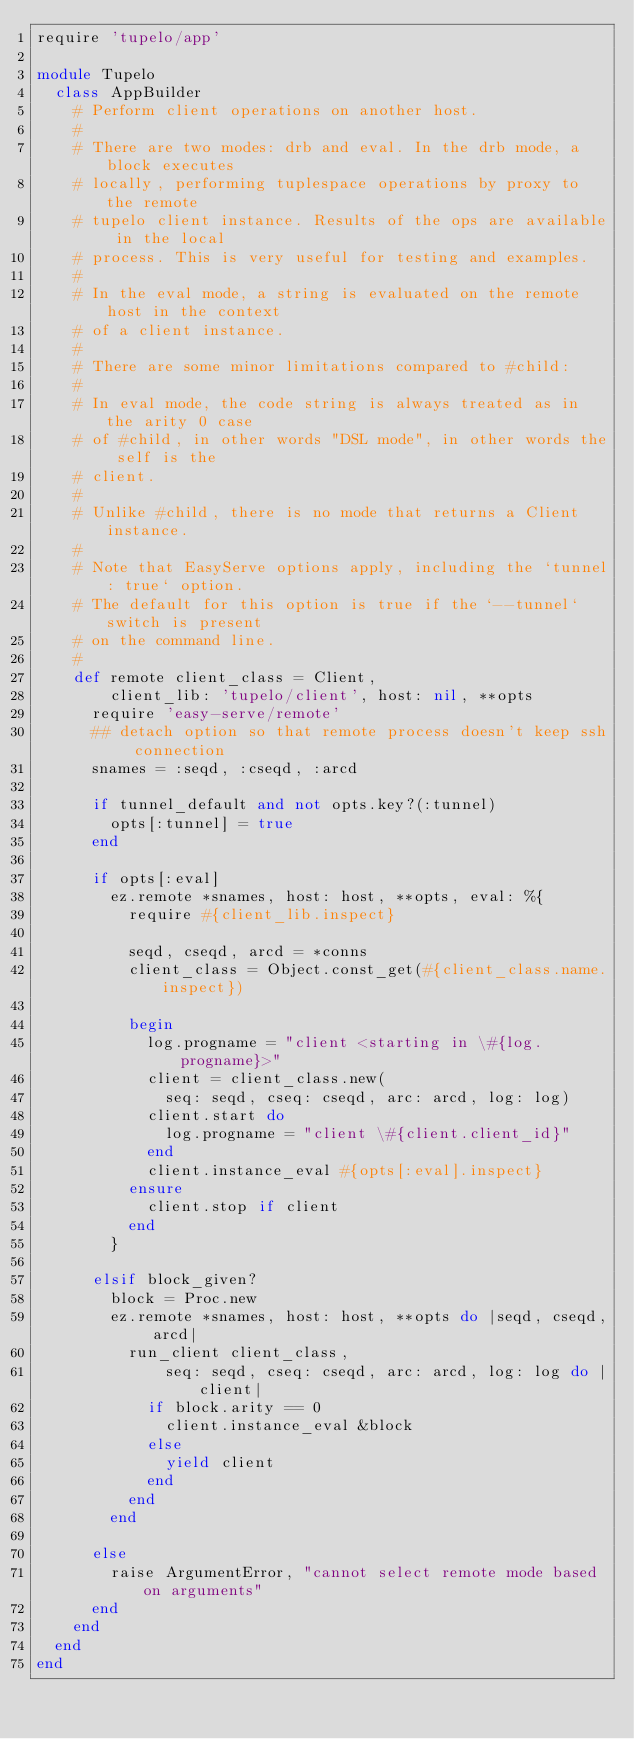<code> <loc_0><loc_0><loc_500><loc_500><_Ruby_>require 'tupelo/app'

module Tupelo
  class AppBuilder
    # Perform client operations on another host.
    #
    # There are two modes: drb and eval. In the drb mode, a block executes
    # locally, performing tuplespace operations by proxy to the remote
    # tupelo client instance. Results of the ops are available in the local
    # process. This is very useful for testing and examples.
    #
    # In the eval mode, a string is evaluated on the remote host in the context
    # of a client instance.
    #
    # There are some minor limitations compared to #child:
    #
    # In eval mode, the code string is always treated as in the arity 0 case
    # of #child, in other words "DSL mode", in other words the self is the
    # client.
    #
    # Unlike #child, there is no mode that returns a Client instance.
    #
    # Note that EasyServe options apply, including the `tunnel: true` option.
    # The default for this option is true if the `--tunnel` switch is present
    # on the command line.
    #
    def remote client_class = Client,
        client_lib: 'tupelo/client', host: nil, **opts
      require 'easy-serve/remote'
      ## detach option so that remote process doesn't keep ssh connection
      snames = :seqd, :cseqd, :arcd

      if tunnel_default and not opts.key?(:tunnel)
        opts[:tunnel] = true
      end

      if opts[:eval]
        ez.remote *snames, host: host, **opts, eval: %{
          require #{client_lib.inspect}

          seqd, cseqd, arcd = *conns
          client_class = Object.const_get(#{client_class.name.inspect})

          begin
            log.progname = "client <starting in \#{log.progname}>"
            client = client_class.new(
              seq: seqd, cseq: cseqd, arc: arcd, log: log)
            client.start do
              log.progname = "client \#{client.client_id}"
            end
            client.instance_eval #{opts[:eval].inspect}
          ensure
            client.stop if client
          end
        }

      elsif block_given?
        block = Proc.new
        ez.remote *snames, host: host, **opts do |seqd, cseqd, arcd|
          run_client client_class,
              seq: seqd, cseq: cseqd, arc: arcd, log: log do |client|
            if block.arity == 0
              client.instance_eval &block
            else
              yield client
            end
          end
        end

      else
        raise ArgumentError, "cannot select remote mode based on arguments"
      end
    end
  end
end
</code> 